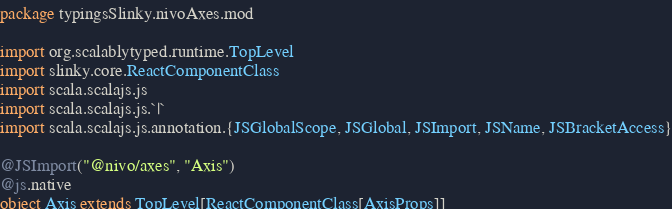<code> <loc_0><loc_0><loc_500><loc_500><_Scala_>package typingsSlinky.nivoAxes.mod

import org.scalablytyped.runtime.TopLevel
import slinky.core.ReactComponentClass
import scala.scalajs.js
import scala.scalajs.js.`|`
import scala.scalajs.js.annotation.{JSGlobalScope, JSGlobal, JSImport, JSName, JSBracketAccess}

@JSImport("@nivo/axes", "Axis")
@js.native
object Axis extends TopLevel[ReactComponentClass[AxisProps]]
</code> 